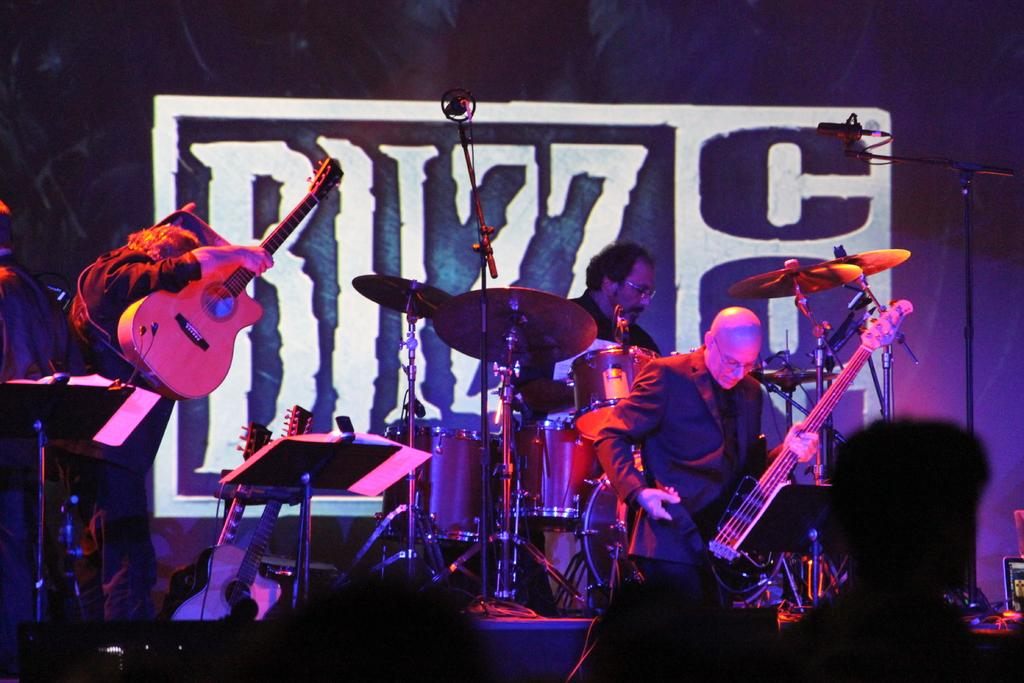What is the person in the foreground of the image wearing? The person in the image is wearing a black dress. What is the person in the black dress holding? The person in the black dress is holding a guitar. What is the other person in the image doing? The person in the background is playing drums. Who is present in front of the musicians? There are audience members in front of the musicians. What type of fire can be seen in the image? There is no fire present in the image. What color are the stockings worn by the person in the black dress? The person in the black dress is not wearing stockings, so we cannot determine their color. 